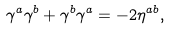<formula> <loc_0><loc_0><loc_500><loc_500>\gamma ^ { a } \gamma ^ { b } + \gamma ^ { b } \gamma ^ { a } = - 2 \eta ^ { a b } ,</formula> 